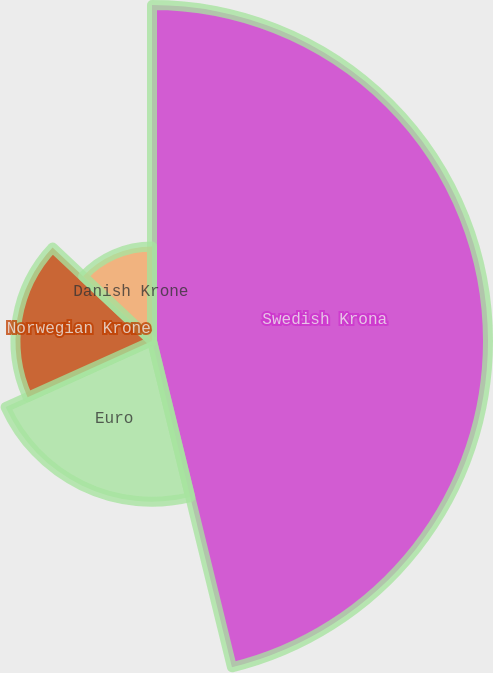Convert chart. <chart><loc_0><loc_0><loc_500><loc_500><pie_chart><fcel>Swedish Krona<fcel>Euro<fcel>Norwegian Krone<fcel>Danish Krone<nl><fcel>46.18%<fcel>22.08%<fcel>18.76%<fcel>12.99%<nl></chart> 